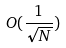Convert formula to latex. <formula><loc_0><loc_0><loc_500><loc_500>O ( \frac { 1 } { \sqrt { N } } )</formula> 